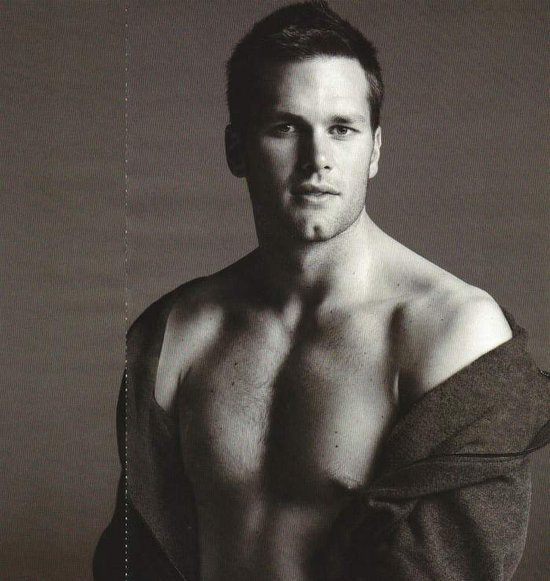What emotions do you think the subject's facial expression conveys, and how does the lighting enhance this expression? The subject's facial expression conveys a mix of introspection and serene confidence. The lighting, coming from one side, enhances these emotions by creating shadows that deepen his facial features, making his expression appear more thoughtful and intense. The way light plays across his face adds a sense of depth and complexity to his gaze, suggesting a contemplative mood. 